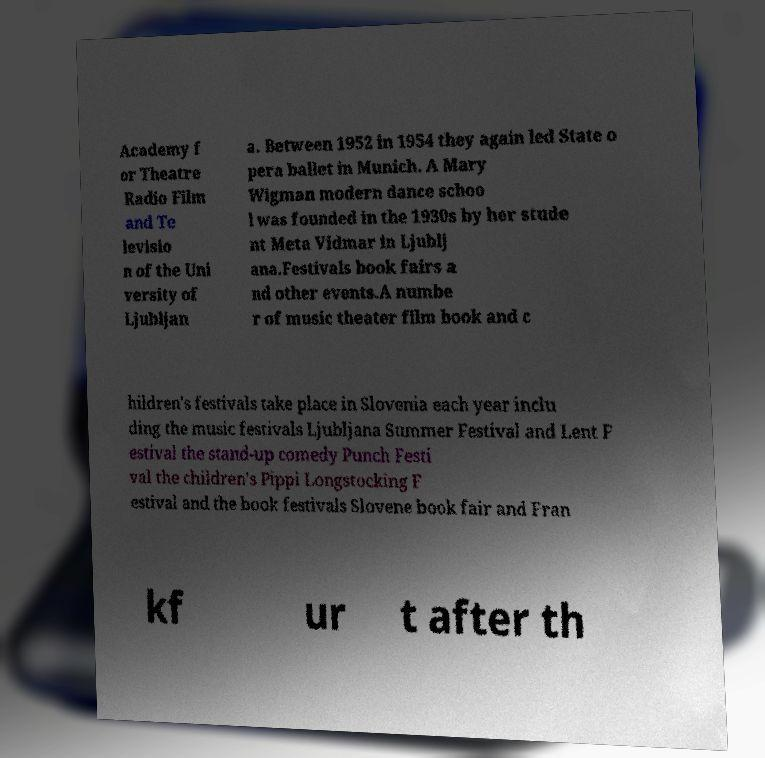I need the written content from this picture converted into text. Can you do that? Academy f or Theatre Radio Film and Te levisio n of the Uni versity of Ljubljan a. Between 1952 in 1954 they again led State o pera ballet in Munich. A Mary Wigman modern dance schoo l was founded in the 1930s by her stude nt Meta Vidmar in Ljublj ana.Festivals book fairs a nd other events.A numbe r of music theater film book and c hildren's festivals take place in Slovenia each year inclu ding the music festivals Ljubljana Summer Festival and Lent F estival the stand-up comedy Punch Festi val the children's Pippi Longstocking F estival and the book festivals Slovene book fair and Fran kf ur t after th 